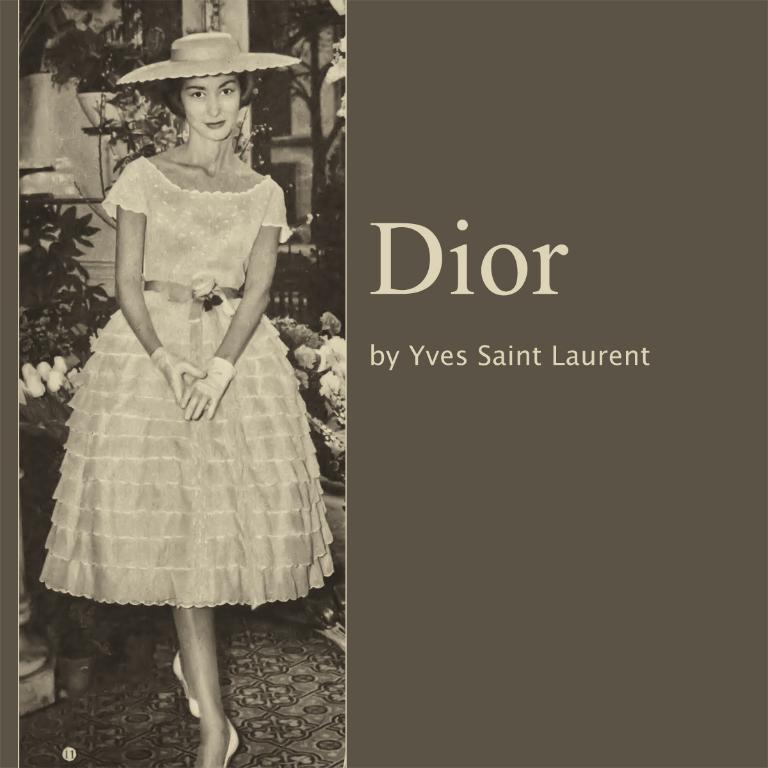<image>
Summarize the visual content of the image. An old Dior ad features a woman wearing a hat. 